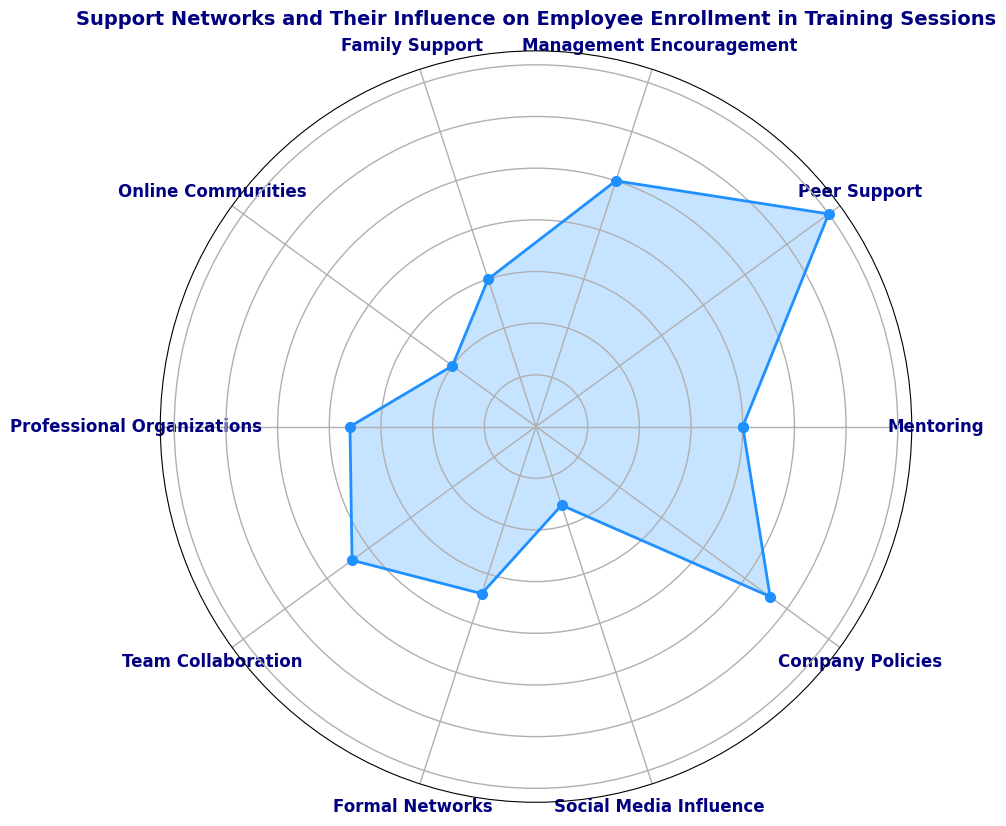Which category has the highest influence on employee enrollment in training sessions? The length of the section representing "Peer Support" is the longest on the chart, indicating it has the highest value.
Answer: Peer Support Which category has the lowest influence on employee enrollment in training sessions? By visually inspecting the chart, "Social Media Influence" has the shortest section, indicating it has the lowest value.
Answer: Social Media Influence What is the difference in influence between Management Encouragement and Family Support? The chart shows that "Management Encouragement" has a value of 25 and "Family Support" has a value of 15. The difference is calculated as 25 - 15.
Answer: 10 If you combine the influence values of Mentoring and Professional Organizations, how much is their total influence? The value for "Mentoring" is 20 and for "Professional Organizations" is 18. Adding these values together: 20 + 18.
Answer: 38 How does the influence of Company Policies compare to that of Team Collaboration? The chart shows that "Company Policies" has a value of 28 and "Team Collaboration" has a value of 22. Therefore, Company Policies have a greater influence.
Answer: Company Policies have a greater influence What is the average influence of all the categories? The sum of the values for all the categories is 20 (Mentoring) + 35 (Peer Support) + 25 (Management Encouragement) + 15 (Family Support) + 10 (Online Communities) + 18 (Professional Organizations) + 22 (Team Collaboration) + 17 (Formal Networks) + 8 (Social Media Influence) + 28 (Company Policies) = 198. There are 10 categories, so the average is 198 / 10.
Answer: 19.8 Which categories fall below the average influence value? The average influence value is 19.8. Categories with values less than 19.8 are "Family Support" (15), "Online Communities" (10), "Professional Organizations" (18), "Formal Networks" (17), and "Social Media Influence" (8).
Answer: Family Support, Online Communities, Professional Organizations, Formal Networks, Social Media Influence How do the combined influences of Peer Support and Company Policies compare to the sum of Team Collaboration and Formal Networks? "Peer Support" has a value of 35 and "Company Policies" has a value of 28, their combined influence is 35 + 28 = 63. "Team Collaboration" has a value of 22 and "Formal Networks" has a value of 17, their combined influence is 22 + 17 = 39. So, 63 is greater than 39.
Answer: The combined influence of Peer Support and Company Policies is greater Among Management Encouragement, Family Support, and Team Collaboration, which one has the median value? Sorting the values of "Management Encouragement" (25), "Family Support" (15), and "Team Collaboration" (22) in ascending order gives [15, 22, 25]. The median value is the middle one, which is 22.
Answer: Team Collaboration 